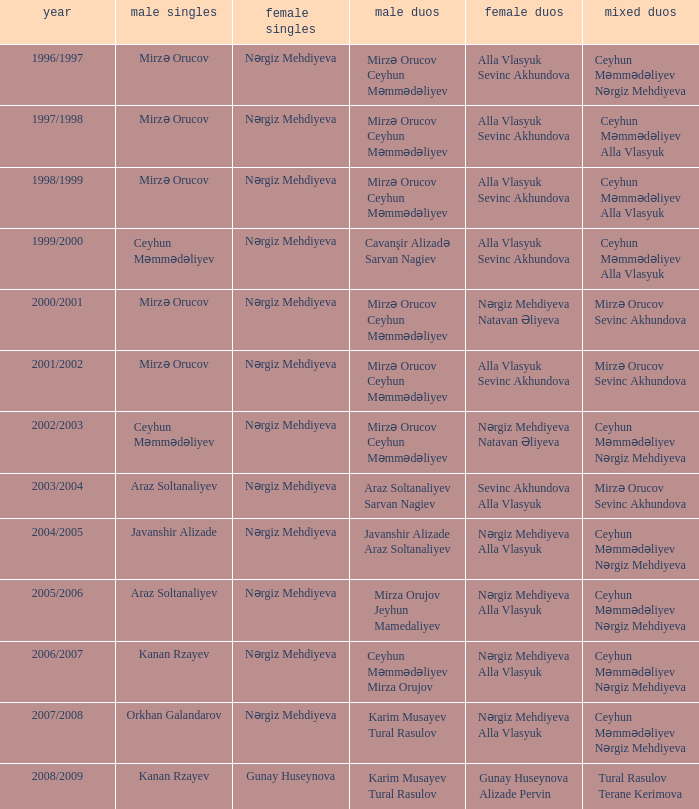What are all values for Womens Doubles in the year 2000/2001? Nərgiz Mehdiyeva Natavan Əliyeva. 